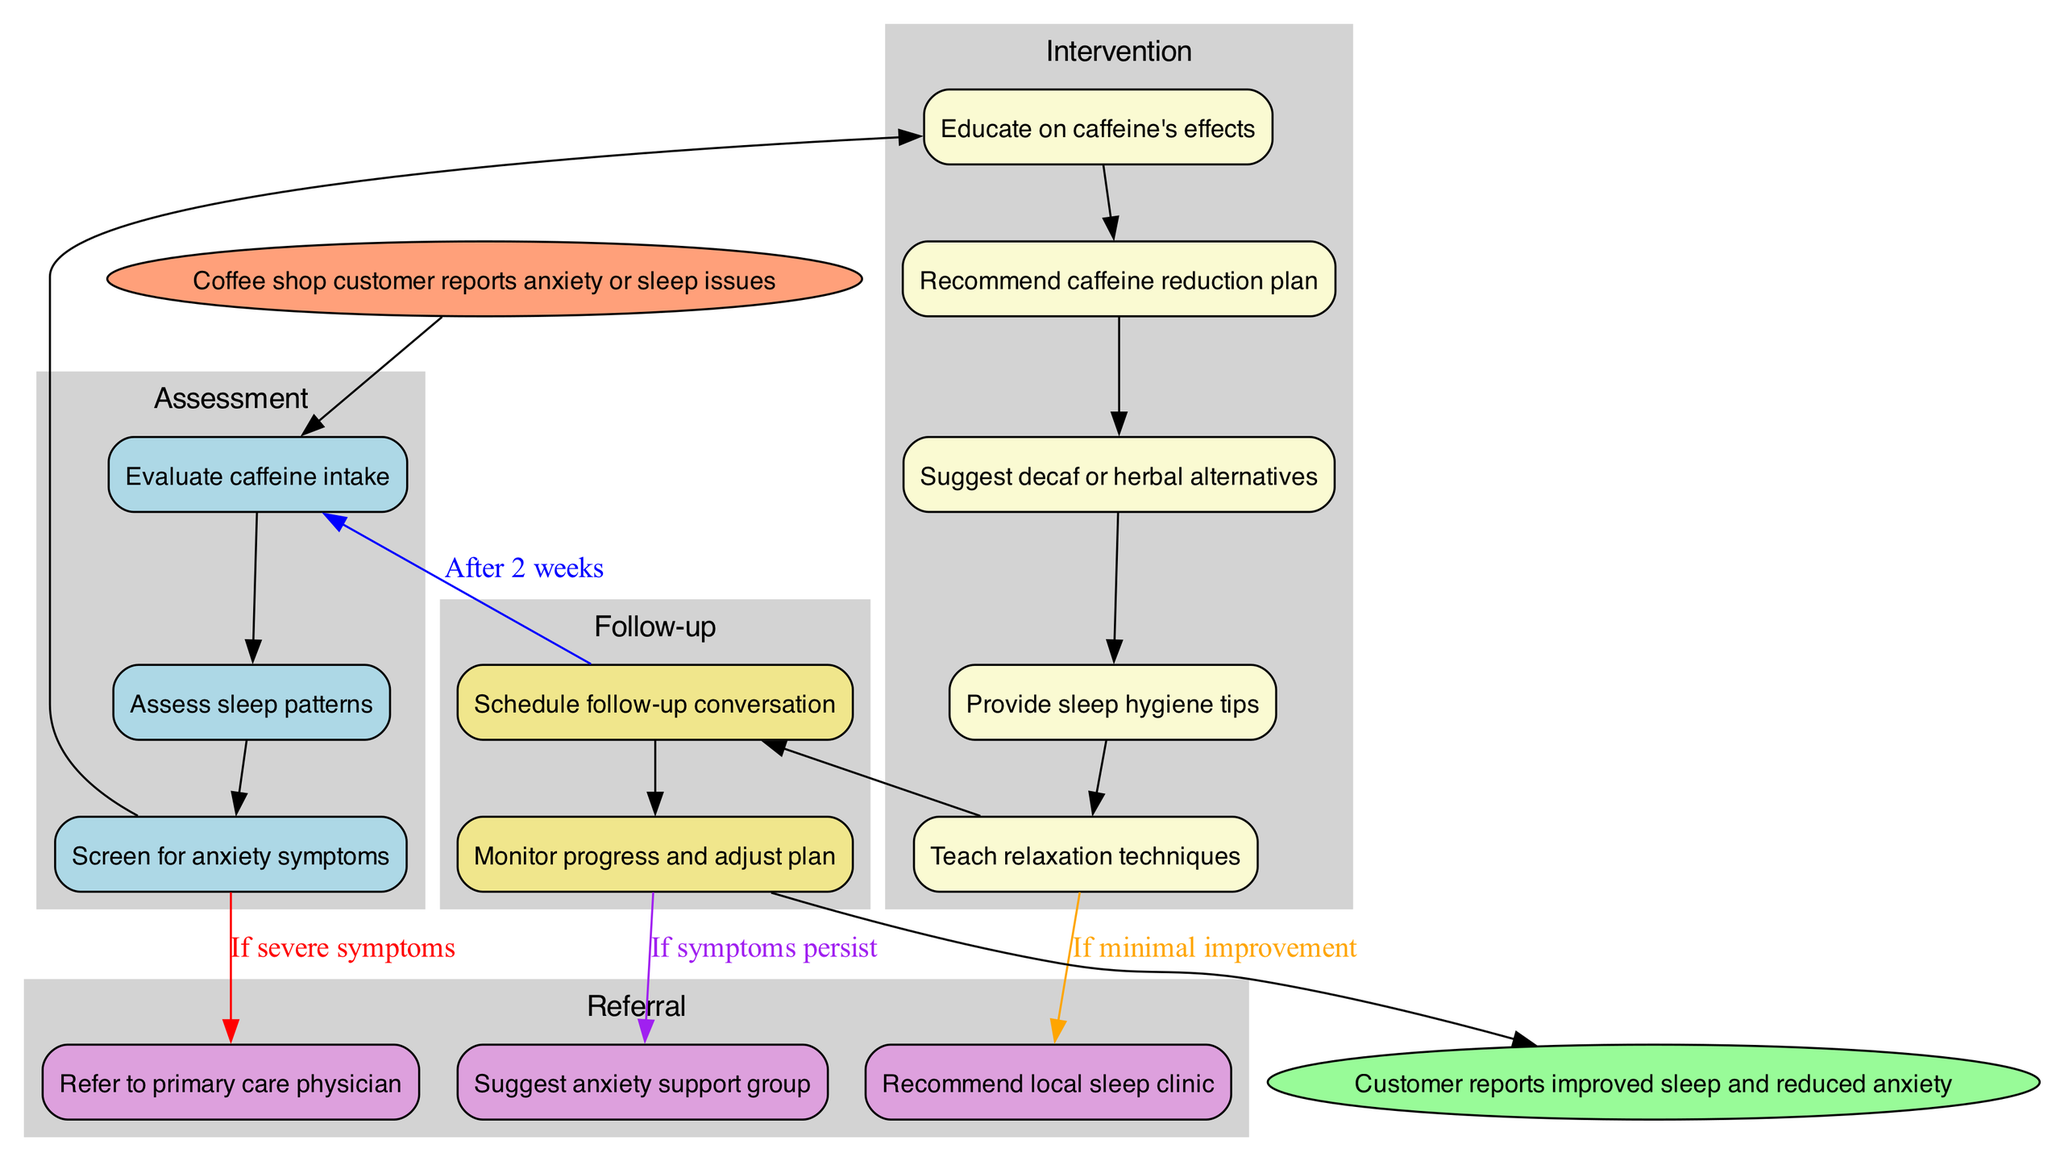What is the starting point of the clinical pathway? The clinical pathway begins at the node labeled "Coffee shop customer reports anxiety or sleep issues." This node indicates the initial step that triggers the subsequent assessments.
Answer: Coffee shop customer reports anxiety or sleep issues How many assessment nodes are present in the diagram? The diagram includes three assessment nodes: "Evaluate caffeine intake," "Assess sleep patterns," and "Screen for anxiety symptoms." Counting them gives a total of three.
Answer: 3 What intervention follows after teaching relaxation techniques? Following the teaching of relaxation techniques, the next intervention node is "Provide sleep hygiene tips." This sequence is observed as part of the intervention flow.
Answer: Provide sleep hygiene tips If symptoms are severe, which referral node is connected? If symptoms are severe, the referral node connected is "Refer to primary care physician." This connection is explicitly indicated by the edge labeled "If severe symptoms."
Answer: Refer to primary care physician What is the endpoint of the clinical pathway? The endpoint of the clinical pathway is "Customer reports improved sleep and reduced anxiety." This represents the ultimate goal of the pathway.
Answer: Customer reports improved sleep and reduced anxiety How many follow-up nodes are present in this diagram? There are two follow-up nodes in the diagram: "Schedule follow-up conversation" and "Monitor progress and adjust plan." Adding them gives a total of two follow-up nodes.
Answer: 2 What happens if symptoms persist after follow-up? If symptoms persist after the follow-up, the patient is directed to "Suggest anxiety support group," as indicated by the edge labeled "If symptoms persist."
Answer: Suggest anxiety support group How many intervention nodes are there in total? The diagram lists five intervention nodes: "Educate on caffeine's effects," "Recommend caffeine reduction plan," "Suggest decaf or herbal alternatives," "Provide sleep hygiene tips," and "Teach relaxation techniques." Counting these gives a total of five intervention nodes.
Answer: 5 What does the edge labeled "After 2 weeks" indicate? The edge labeled "After 2 weeks" indicates a follow-up action, where the plan may be reassessed after a two-week period to monitor progress and make adjustments based on the customer's situation.
Answer: Monitor progress and adjust plan 